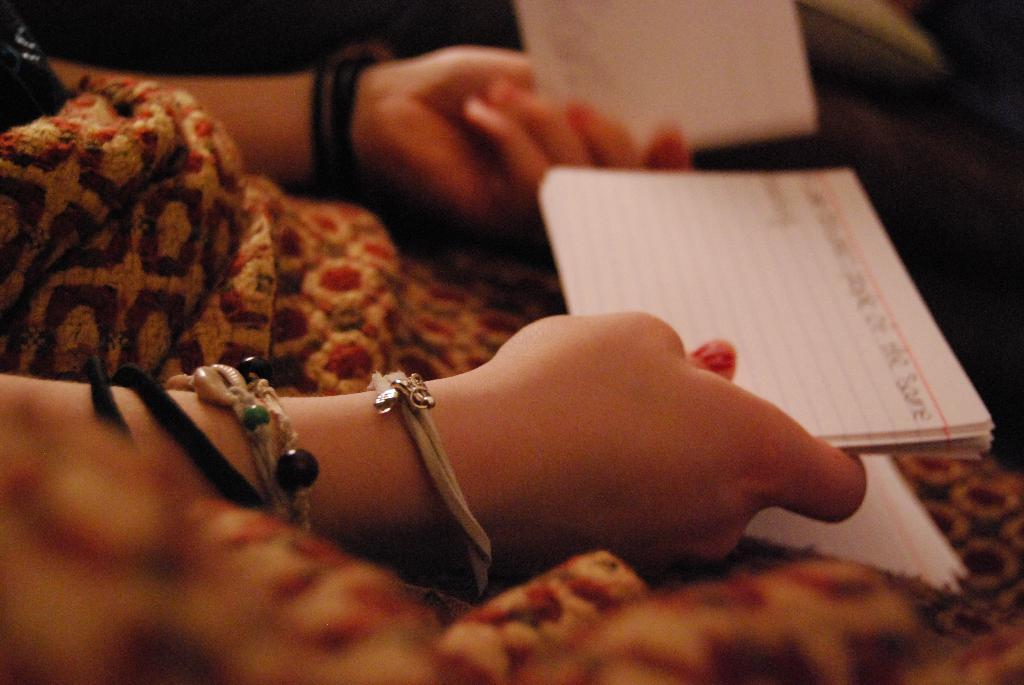Who is the main subject in the image? There is a woman in the image. What is the woman holding in her hands? The woman is holding books in her hands. Where is the faucet located in the image? There is no faucet present in the image. What type of ray is flying in the background of the image? There is no ray present in the image. 